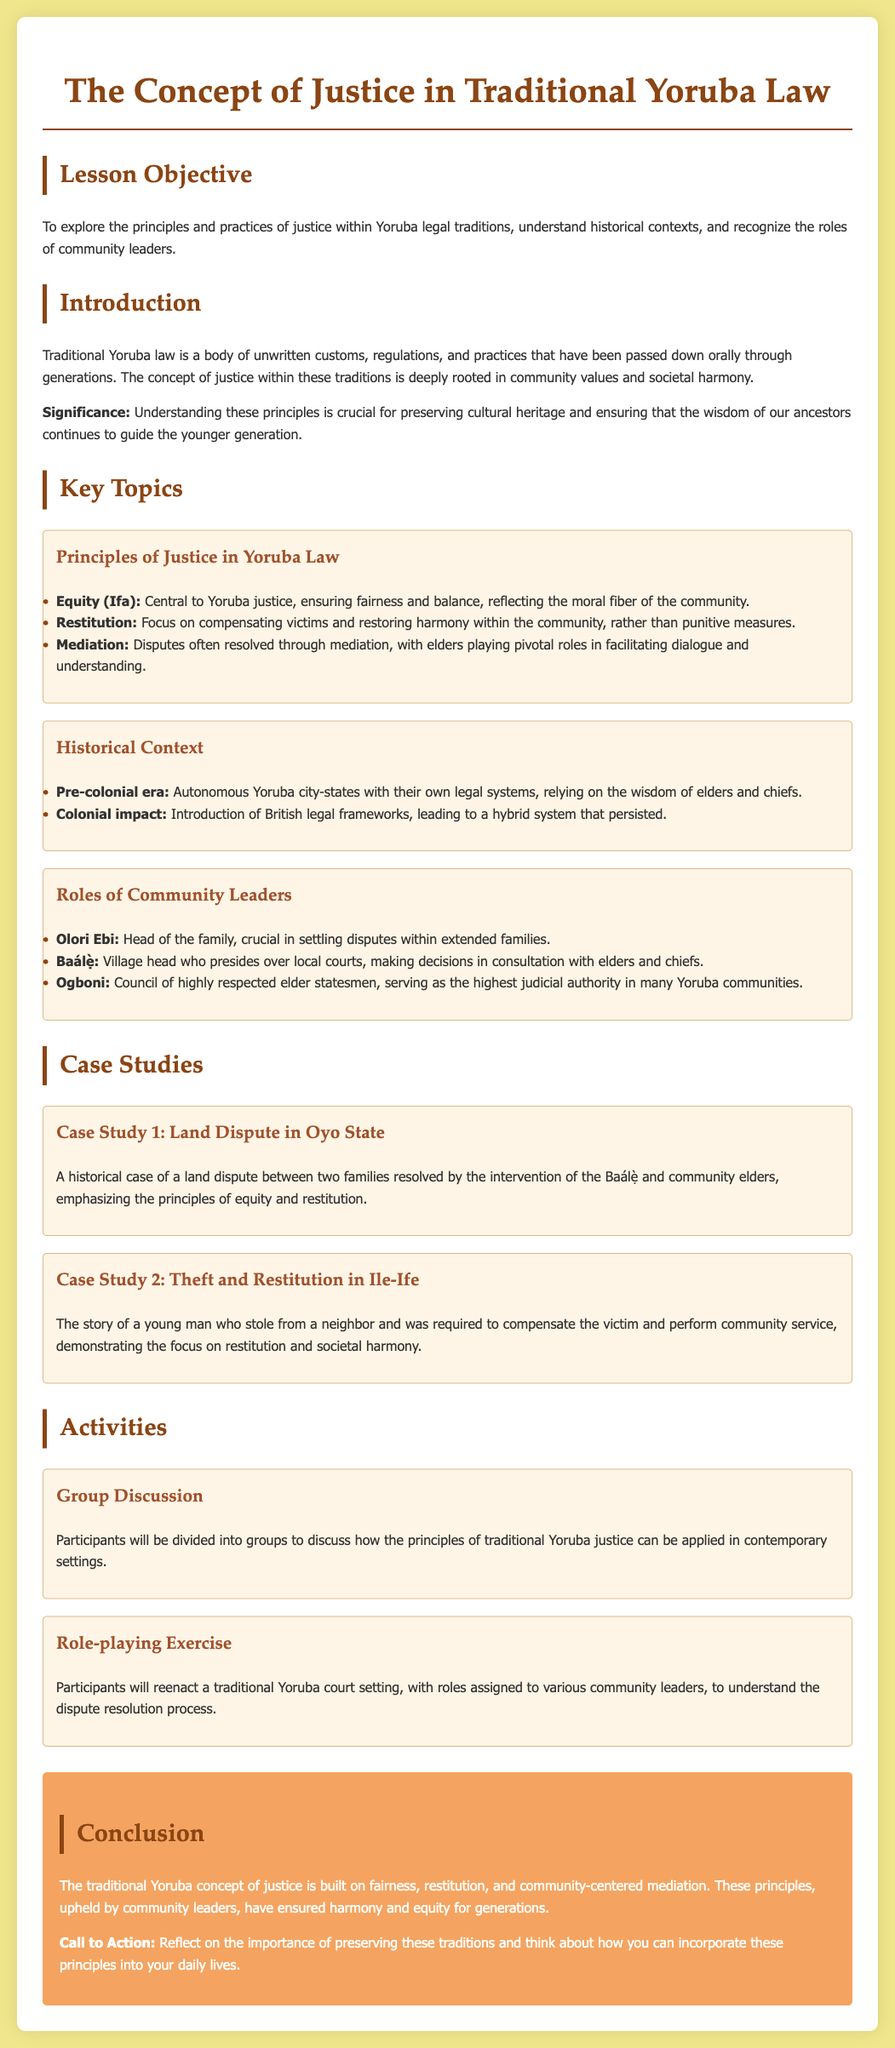what is the central principle of justice in Yoruba law? The central principle of justice in Yoruba law is equity, which is crucial for ensuring fairness and balance.
Answer: equity (Ifa) who plays a pivotal role in mediating disputes? Elders are pivotal in mediating disputes within the community, facilitating dialogue and understanding.
Answer: elders what is emphasized in the case study of theft in Ile-Ife? The case study emphasizes restitution, requiring the young man to compensate the victim and perform community service.
Answer: restitution who is responsible for settling disputes within extended families? The head of the family, known as the Olori Ebi, is responsible for settling disputes within extended families.
Answer: Olori Ebi what historical impact influenced Yoruba legal traditions? The introduction of British legal frameworks during the colonial period influenced Yoruba legal traditions, leading to a hybrid system.
Answer: colonial impact 